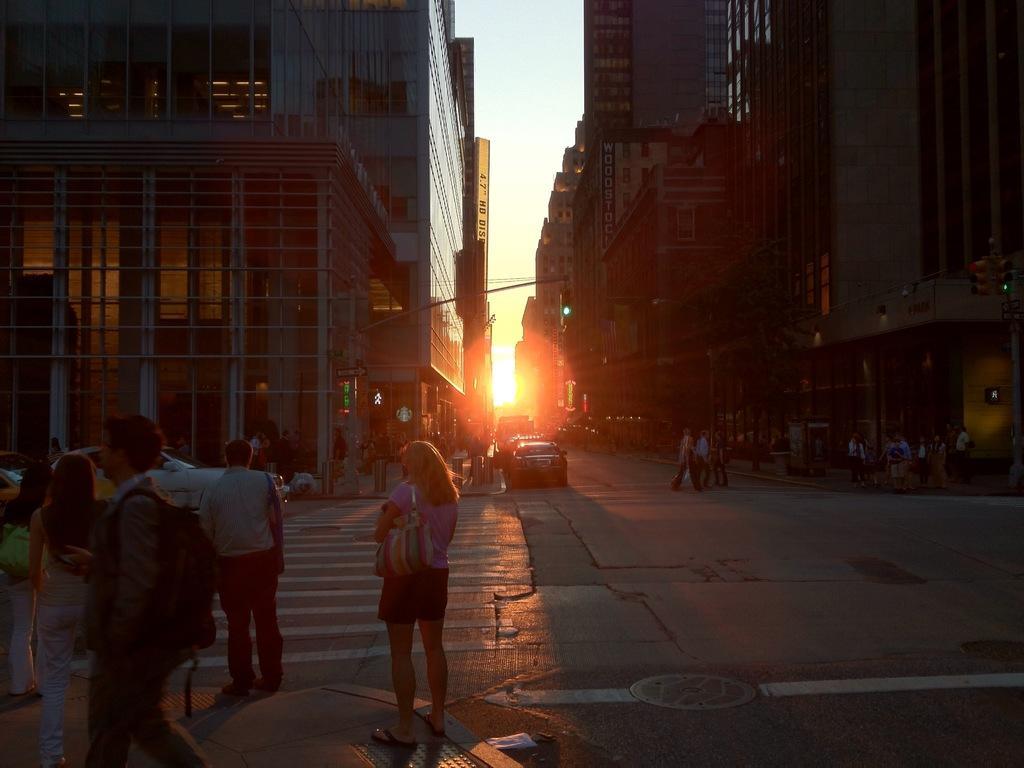Could you give a brief overview of what you see in this image? In this image, on the left side, we can see a group of people. On the right side, we can also see a group of people. In the background, we can see some vehicles, buildings, sun. At the top, we can see a sky. 